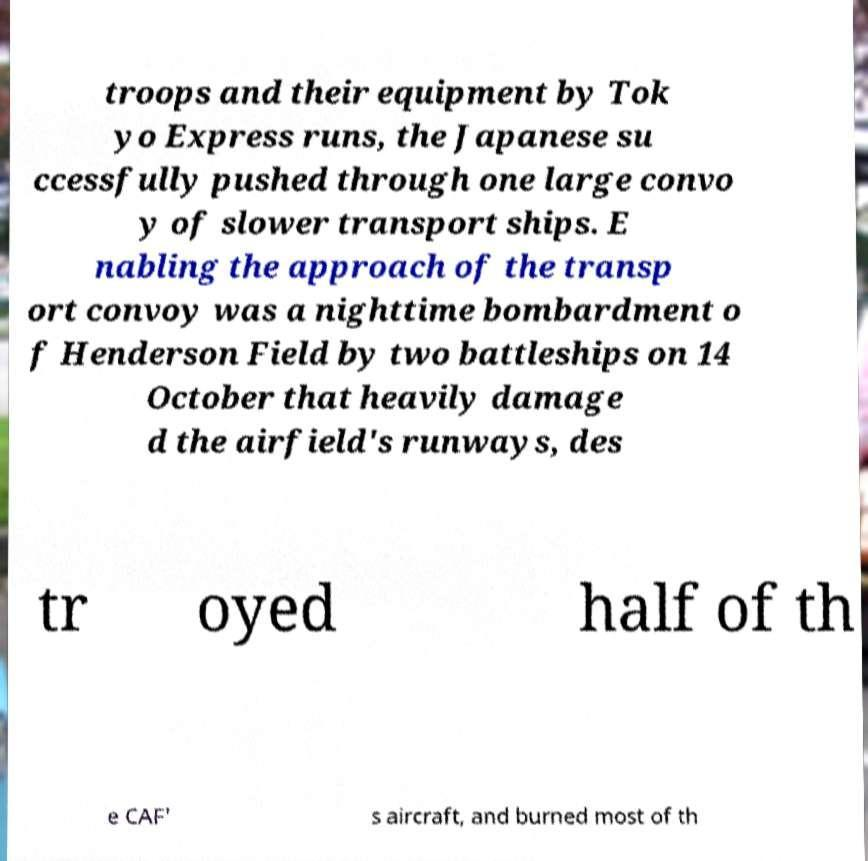Can you read and provide the text displayed in the image?This photo seems to have some interesting text. Can you extract and type it out for me? troops and their equipment by Tok yo Express runs, the Japanese su ccessfully pushed through one large convo y of slower transport ships. E nabling the approach of the transp ort convoy was a nighttime bombardment o f Henderson Field by two battleships on 14 October that heavily damage d the airfield's runways, des tr oyed half of th e CAF' s aircraft, and burned most of th 